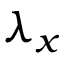Convert formula to latex. <formula><loc_0><loc_0><loc_500><loc_500>\lambda _ { x }</formula> 